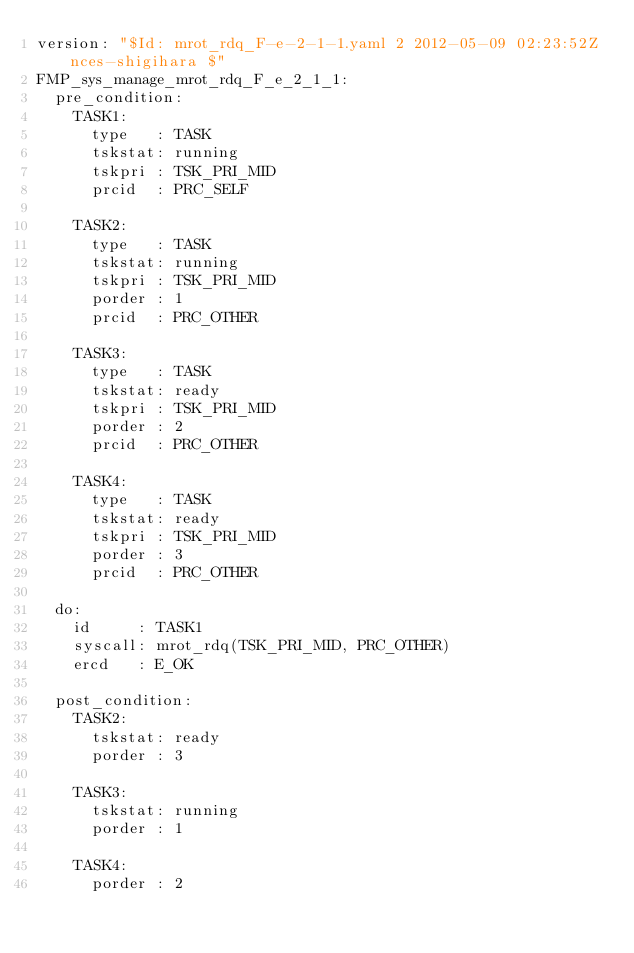Convert code to text. <code><loc_0><loc_0><loc_500><loc_500><_YAML_>version: "$Id: mrot_rdq_F-e-2-1-1.yaml 2 2012-05-09 02:23:52Z nces-shigihara $"
FMP_sys_manage_mrot_rdq_F_e_2_1_1:
  pre_condition:
    TASK1:
      type   : TASK
      tskstat: running
      tskpri : TSK_PRI_MID
      prcid  : PRC_SELF

    TASK2:
      type   : TASK
      tskstat: running
      tskpri : TSK_PRI_MID
      porder : 1
      prcid  : PRC_OTHER

    TASK3:
      type   : TASK
      tskstat: ready
      tskpri : TSK_PRI_MID
      porder : 2
      prcid  : PRC_OTHER

    TASK4:
      type   : TASK
      tskstat: ready
      tskpri : TSK_PRI_MID
      porder : 3
      prcid  : PRC_OTHER

  do:
    id     : TASK1
    syscall: mrot_rdq(TSK_PRI_MID, PRC_OTHER)
    ercd   : E_OK

  post_condition:
    TASK2:
      tskstat: ready
      porder : 3

    TASK3:
      tskstat: running
      porder : 1

    TASK4:
      porder : 2
</code> 